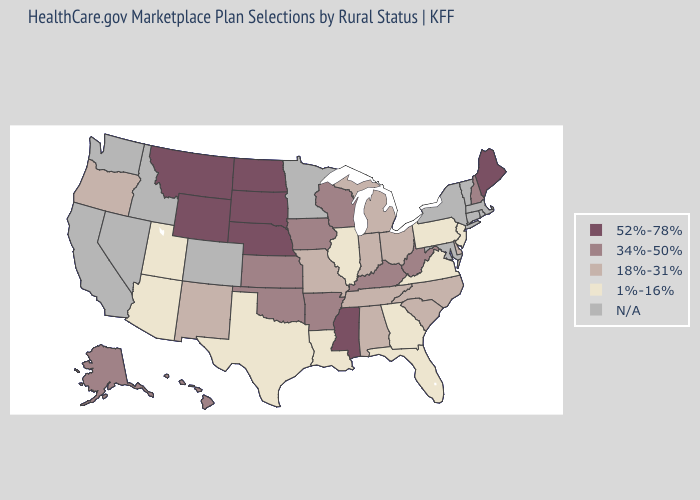What is the value of Arizona?
Give a very brief answer. 1%-16%. Does North Dakota have the lowest value in the USA?
Be succinct. No. Which states have the lowest value in the MidWest?
Be succinct. Illinois. What is the highest value in states that border Colorado?
Be succinct. 52%-78%. Does Utah have the lowest value in the USA?
Concise answer only. Yes. Does the first symbol in the legend represent the smallest category?
Keep it brief. No. What is the lowest value in states that border Massachusetts?
Quick response, please. 34%-50%. What is the value of Kansas?
Answer briefly. 34%-50%. Name the states that have a value in the range N/A?
Answer briefly. California, Colorado, Connecticut, Idaho, Maryland, Massachusetts, Minnesota, Nevada, New York, Rhode Island, Vermont, Washington. What is the value of Wyoming?
Keep it brief. 52%-78%. 